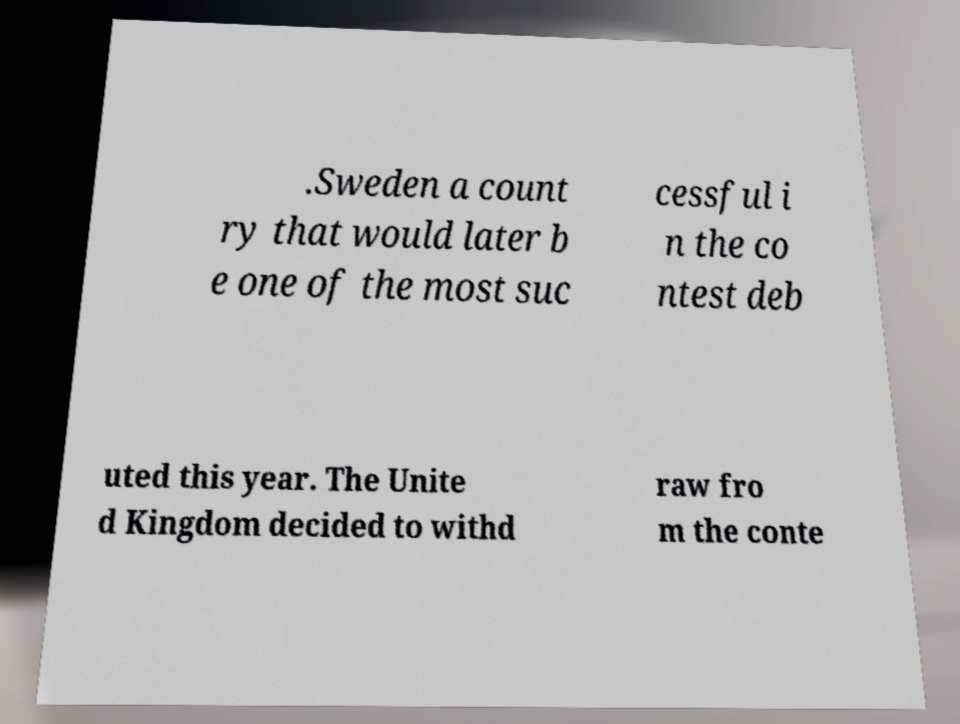Could you assist in decoding the text presented in this image and type it out clearly? .Sweden a count ry that would later b e one of the most suc cessful i n the co ntest deb uted this year. The Unite d Kingdom decided to withd raw fro m the conte 